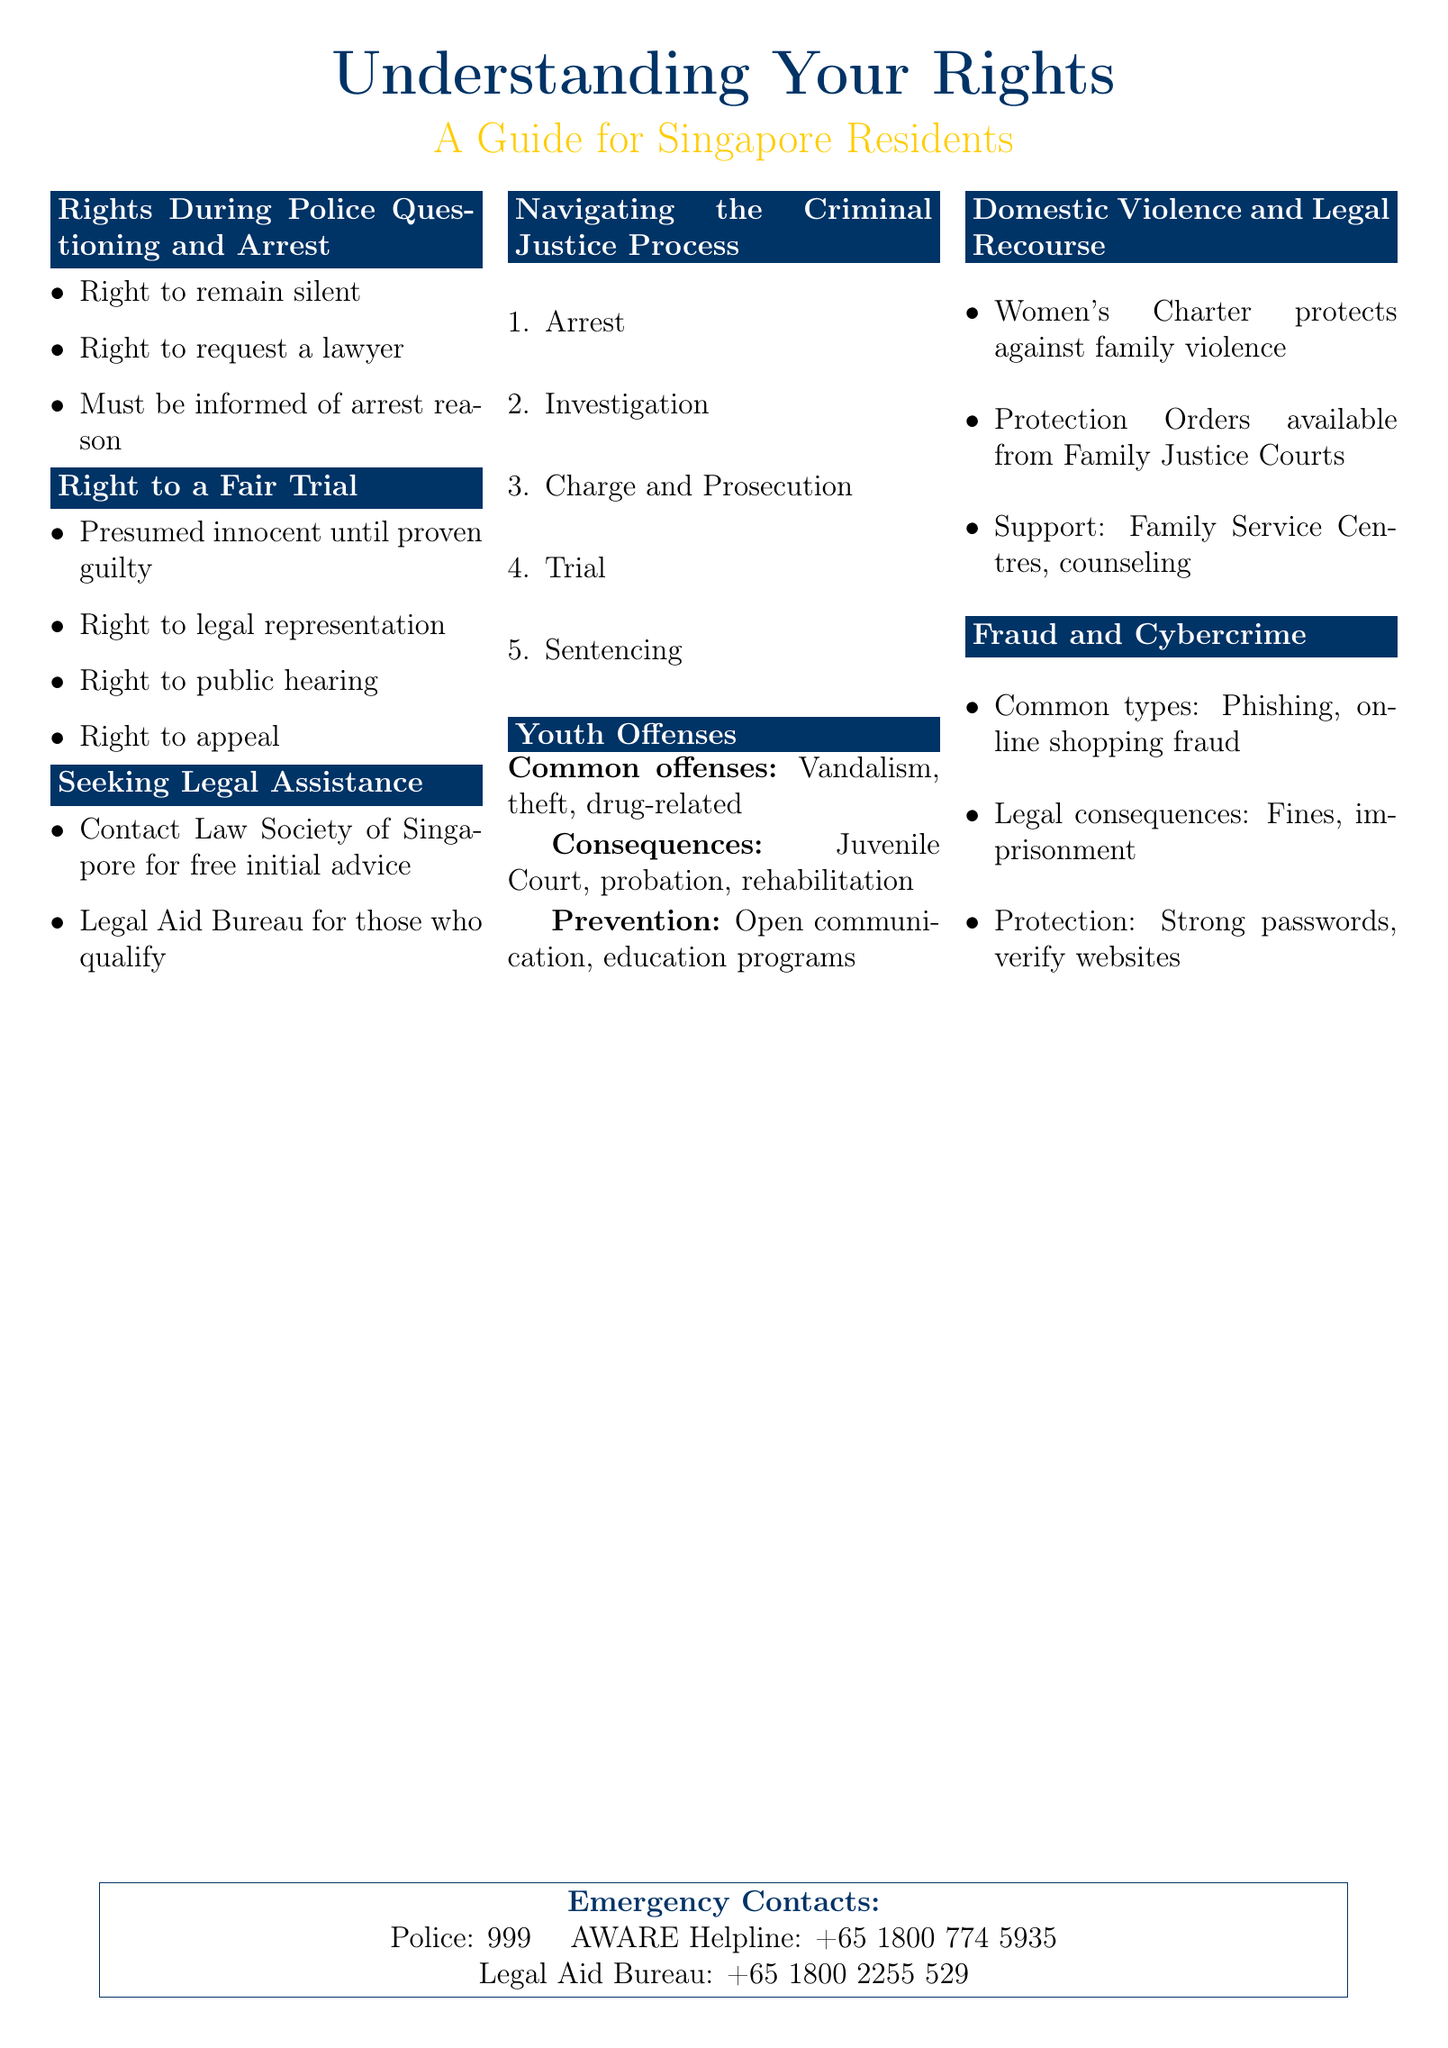What are the rights during police questioning? The document lists the rights individuals have during police questioning, including the right to remain silent and to request a lawyer.
Answer: Right to remain silent, right to request a lawyer What is the legal recourse for domestic violence in Singapore? The flyer explains the Women's Charter and the option for victims to obtain Protection Orders from the Family Justice Courts.
Answer: Women's Charter, Protection Orders What is one common youth offense mentioned? The document outlines common offenses committed by youth, including vandalism and theft.
Answer: Vandalism How many key stages are there in the criminal justice process? The flyer provides a step-by-step guide to the criminal justice process, detailing five key stages.
Answer: Five What organization can you contact for free initial legal advice? The document recommends contacting the Law Society of Singapore for free initial advice regarding legal matters.
Answer: Law Society of Singapore What is one helpful tip for preventing youth offenses? The flyer suggests open communication and education programs as preventive measures for youth offenses.
Answer: Open communication What are common types of fraud mentioned in the document? The flyer educates the public about types of fraud, including phishing and online shopping fraud.
Answer: Phishing, online shopping fraud What is the contact number for the Legal Aid Bureau? The document provides the contact number for the Legal Aid Bureau for individuals needing legal assistance.
Answer: +65 1800 2255 529 What is the presumption of innocence? The flyer states that individuals are presumed innocent until proven guilty in the context of a fair trial.
Answer: Presumed innocent until proven guilty 